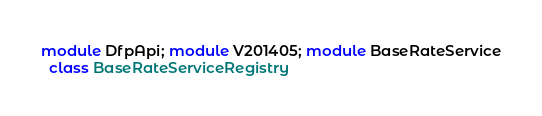Convert code to text. <code><loc_0><loc_0><loc_500><loc_500><_Ruby_>module DfpApi; module V201405; module BaseRateService
  class BaseRateServiceRegistry</code> 